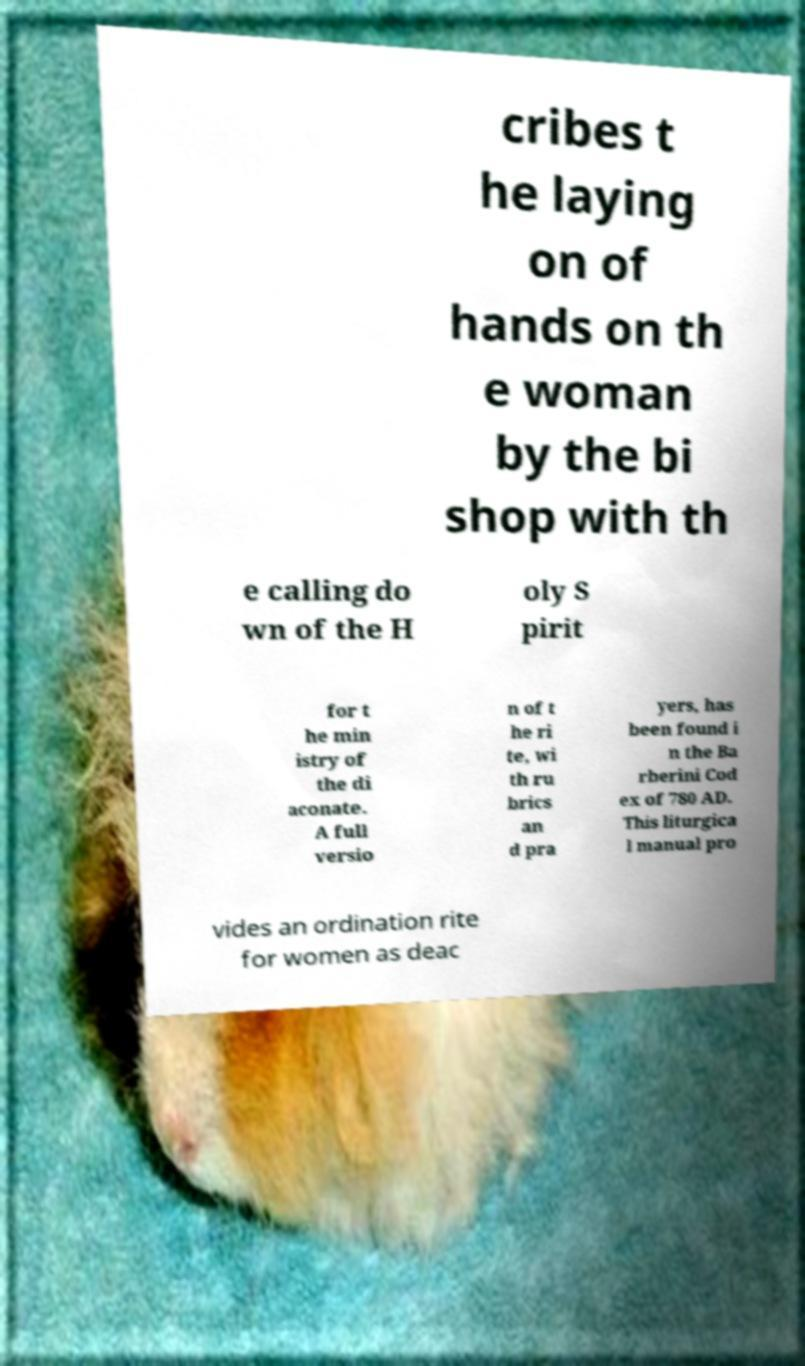Could you assist in decoding the text presented in this image and type it out clearly? cribes t he laying on of hands on th e woman by the bi shop with th e calling do wn of the H oly S pirit for t he min istry of the di aconate. A full versio n of t he ri te, wi th ru brics an d pra yers, has been found i n the Ba rberini Cod ex of 780 AD. This liturgica l manual pro vides an ordination rite for women as deac 